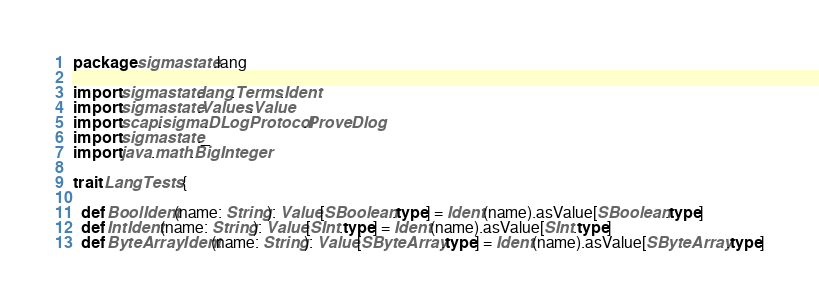Convert code to text. <code><loc_0><loc_0><loc_500><loc_500><_Scala_>package sigmastate.lang

import sigmastate.lang.Terms.Ident
import sigmastate.Values.Value
import scapi.sigma.DLogProtocol.ProveDlog
import sigmastate._
import java.math.BigInteger

trait LangTests {

  def BoolIdent(name: String): Value[SBoolean.type] = Ident(name).asValue[SBoolean.type]
  def IntIdent(name: String): Value[SInt.type] = Ident(name).asValue[SInt.type]
  def ByteArrayIdent(name: String): Value[SByteArray.type] = Ident(name).asValue[SByteArray.type]</code> 